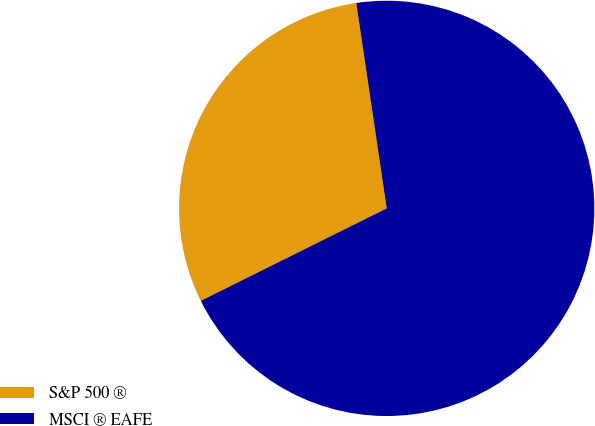Convert chart to OTSL. <chart><loc_0><loc_0><loc_500><loc_500><pie_chart><fcel>S&P 500 ®<fcel>MSCI ® EAFE<nl><fcel>30.0%<fcel>70.0%<nl></chart> 